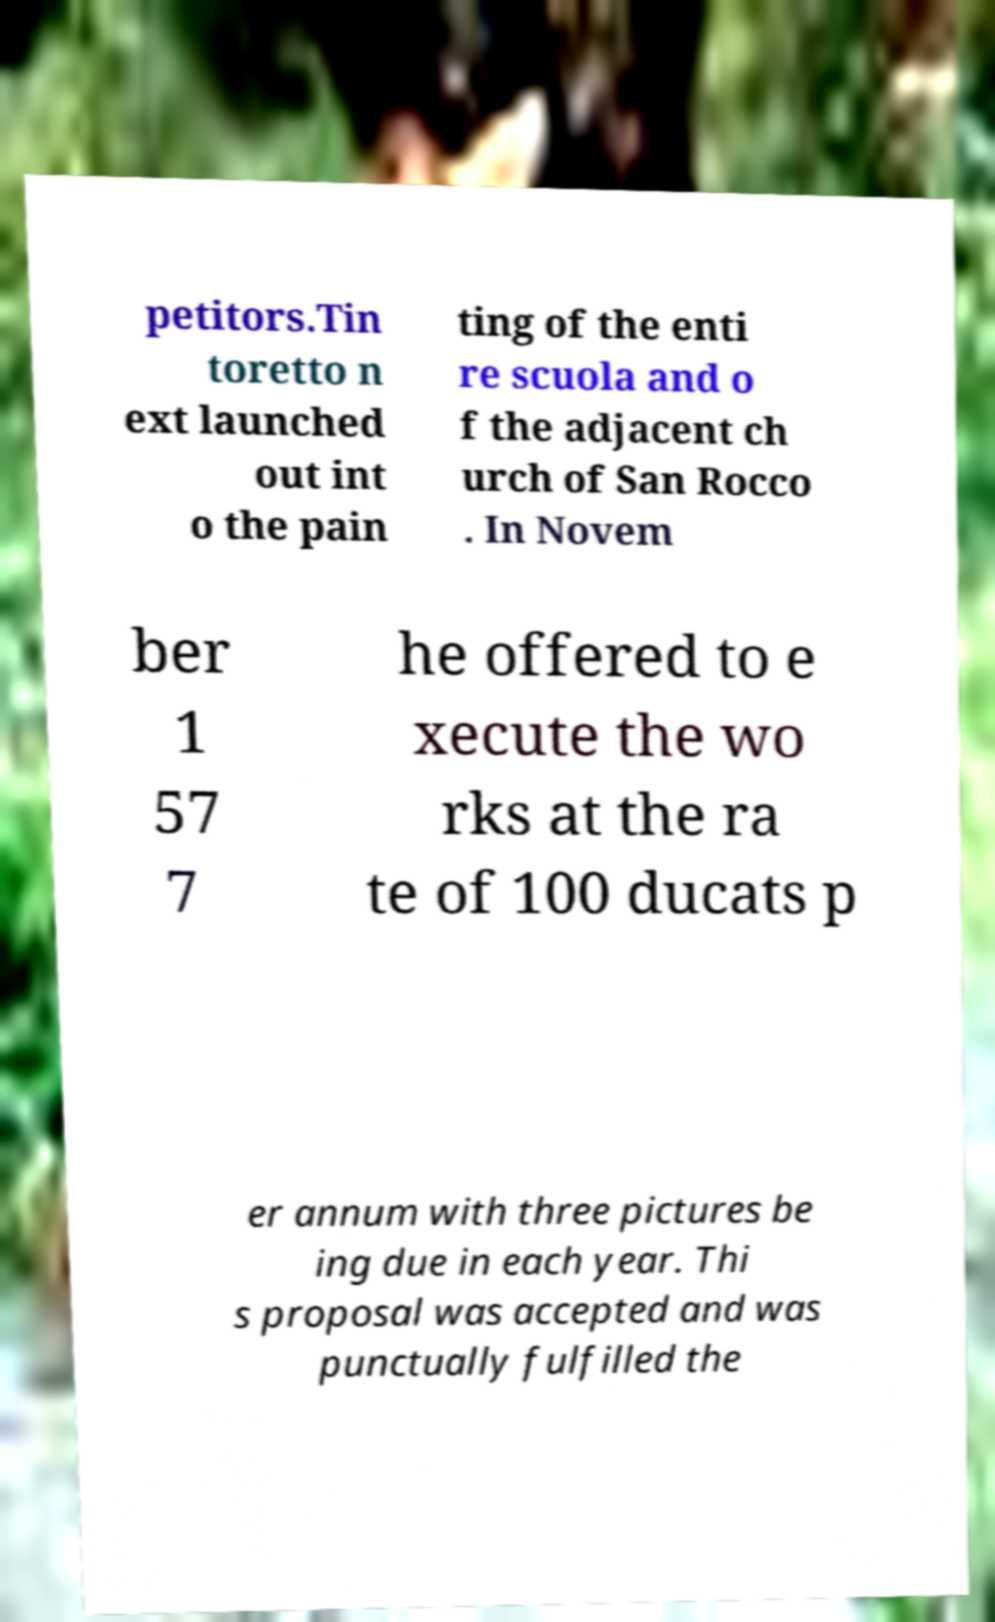Can you accurately transcribe the text from the provided image for me? petitors.Tin toretto n ext launched out int o the pain ting of the enti re scuola and o f the adjacent ch urch of San Rocco . In Novem ber 1 57 7 he offered to e xecute the wo rks at the ra te of 100 ducats p er annum with three pictures be ing due in each year. Thi s proposal was accepted and was punctually fulfilled the 